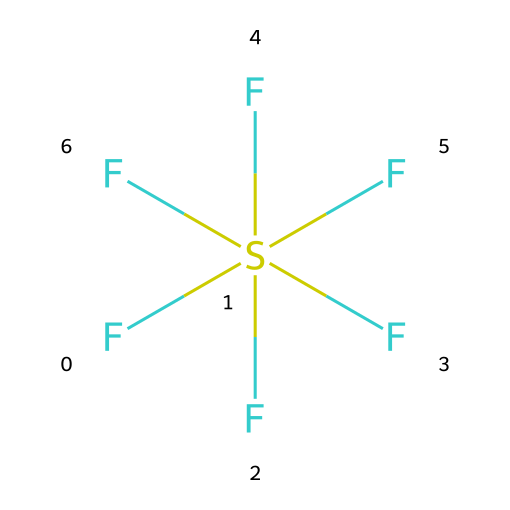What is the name of this chemical? The chemical structure shows a sulfur atom bonded to six fluorine atoms, which is known as sulfur hexafluoride.
Answer: sulfur hexafluoride How many total atoms are present in this molecule? The molecule consists of one sulfur atom and six fluorine atoms, totaling seven atoms.
Answer: seven What type of hybridization is present in sulfur hexafluoride? The sulfur atom has six equivalent bonds with fluorine, suggesting an octahedral geometry, which corresponds to sp3d2 hybridization.
Answer: sp3d2 What is the total number of fluorine atoms in this compound? The chemical structure clearly shows six fluorine atoms bonded to the sulfur atom.
Answer: six Is sulfur hexafluoride a hypervalent compound? Yes, sulfur hexafluoride is a hypervalent compound because the sulfur atom can expand its valence shell to accommodate more than eight electrons, in this case six from the bonds with fluorine.
Answer: yes What is the molecular geometry of sulfur hexafluoride? The presence of six fluorine atoms symmetrically arranged around a central sulfur atom results in an octahedral molecular geometry.
Answer: octahedral What is the primary use of sulfur hexafluoride? Sulfur hexafluoride is primarily used in electrical insulation applications due to its excellent dielectric properties.
Answer: electrical insulation 